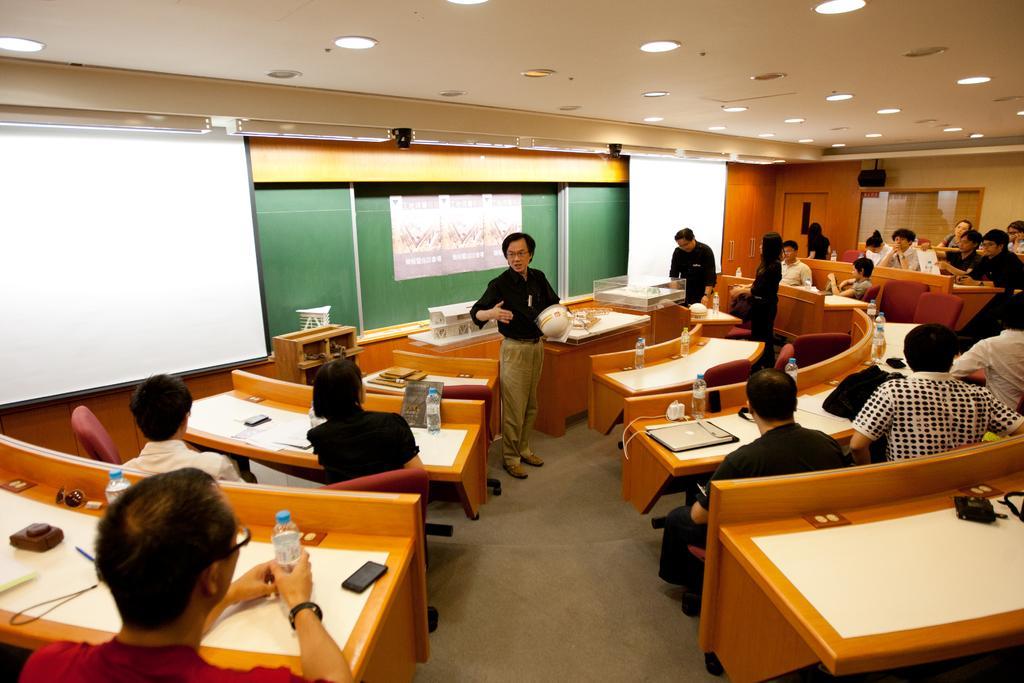In one or two sentences, can you explain what this image depicts? In this image I can see a group of people sitting on the bench. On the table there is a water bottle,mobile,laptop and a papers. In front the man is standing and holding a helmet. At the back side I can see aboard and a screen. The wall is in orange color. 